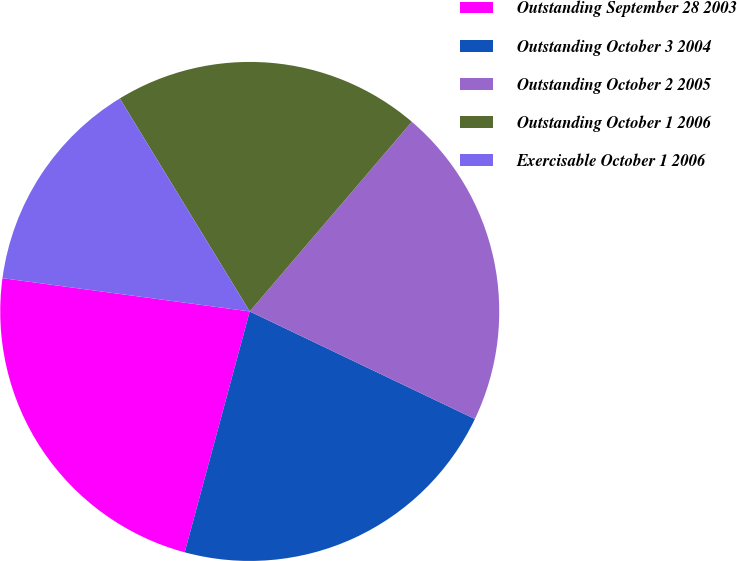Convert chart. <chart><loc_0><loc_0><loc_500><loc_500><pie_chart><fcel>Outstanding September 28 2003<fcel>Outstanding October 3 2004<fcel>Outstanding October 2 2005<fcel>Outstanding October 1 2006<fcel>Exercisable October 1 2006<nl><fcel>22.93%<fcel>22.1%<fcel>20.84%<fcel>19.97%<fcel>14.15%<nl></chart> 